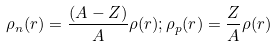Convert formula to latex. <formula><loc_0><loc_0><loc_500><loc_500>\rho _ { n } ( r ) = \frac { ( A - Z ) } { A } \rho ( r ) ; \rho _ { p } ( r ) = \frac { Z } { A } \rho ( r )</formula> 